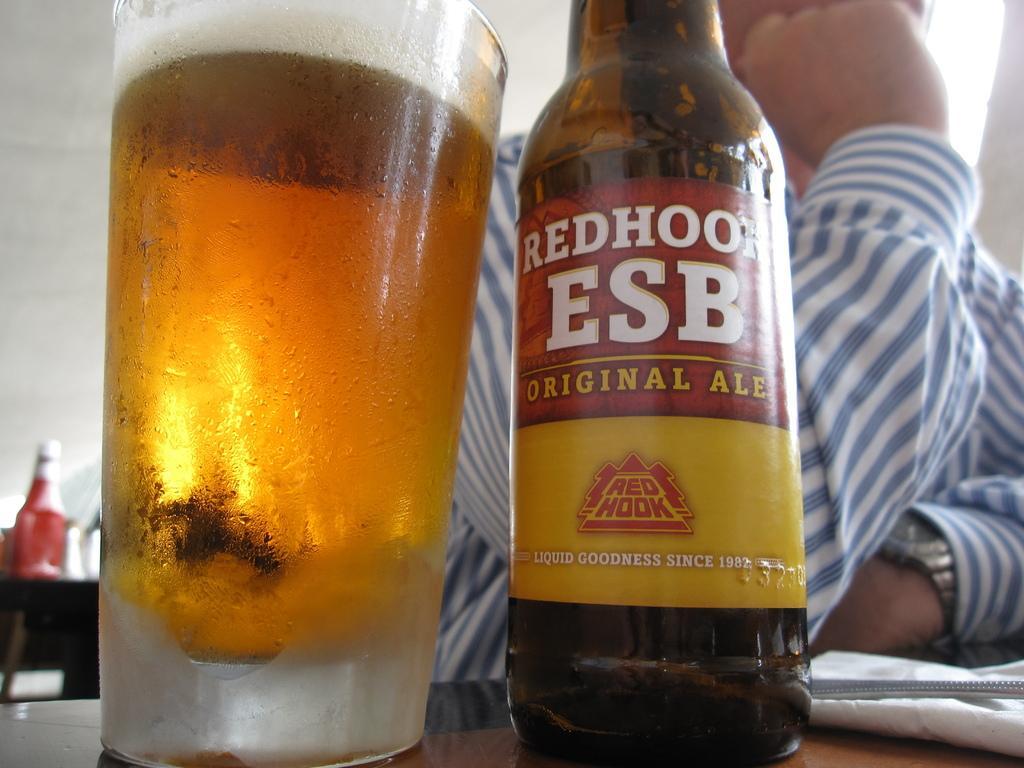Can you describe this image briefly? In this image there is a bottle of beer on the table, beside the beer there is a glass of beer, behind the bottle there is a person. 